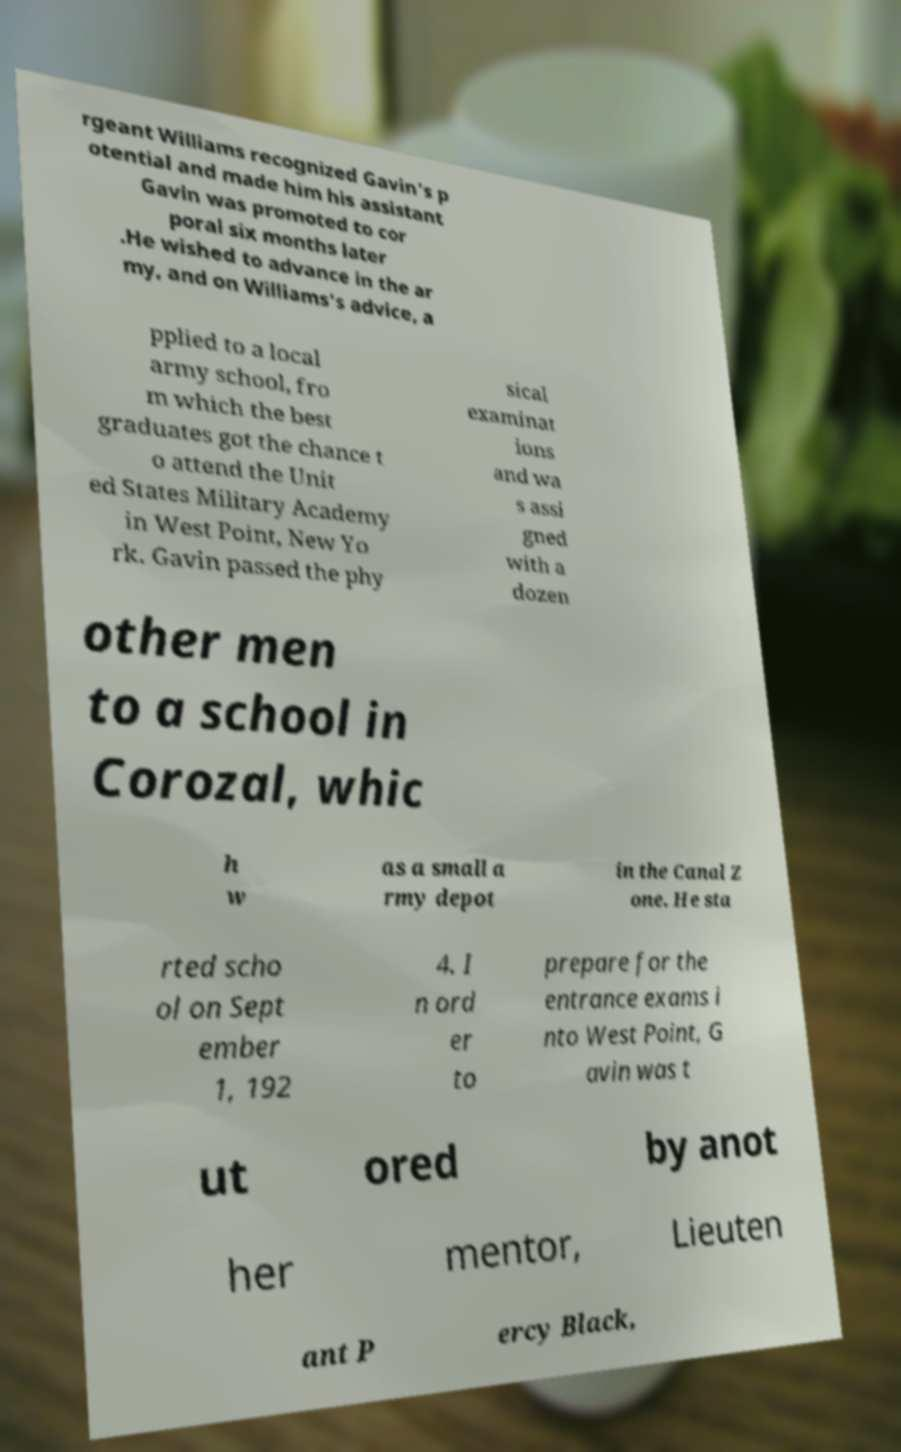I need the written content from this picture converted into text. Can you do that? rgeant Williams recognized Gavin's p otential and made him his assistant Gavin was promoted to cor poral six months later .He wished to advance in the ar my, and on Williams's advice, a pplied to a local army school, fro m which the best graduates got the chance t o attend the Unit ed States Military Academy in West Point, New Yo rk. Gavin passed the phy sical examinat ions and wa s assi gned with a dozen other men to a school in Corozal, whic h w as a small a rmy depot in the Canal Z one. He sta rted scho ol on Sept ember 1, 192 4. I n ord er to prepare for the entrance exams i nto West Point, G avin was t ut ored by anot her mentor, Lieuten ant P ercy Black, 